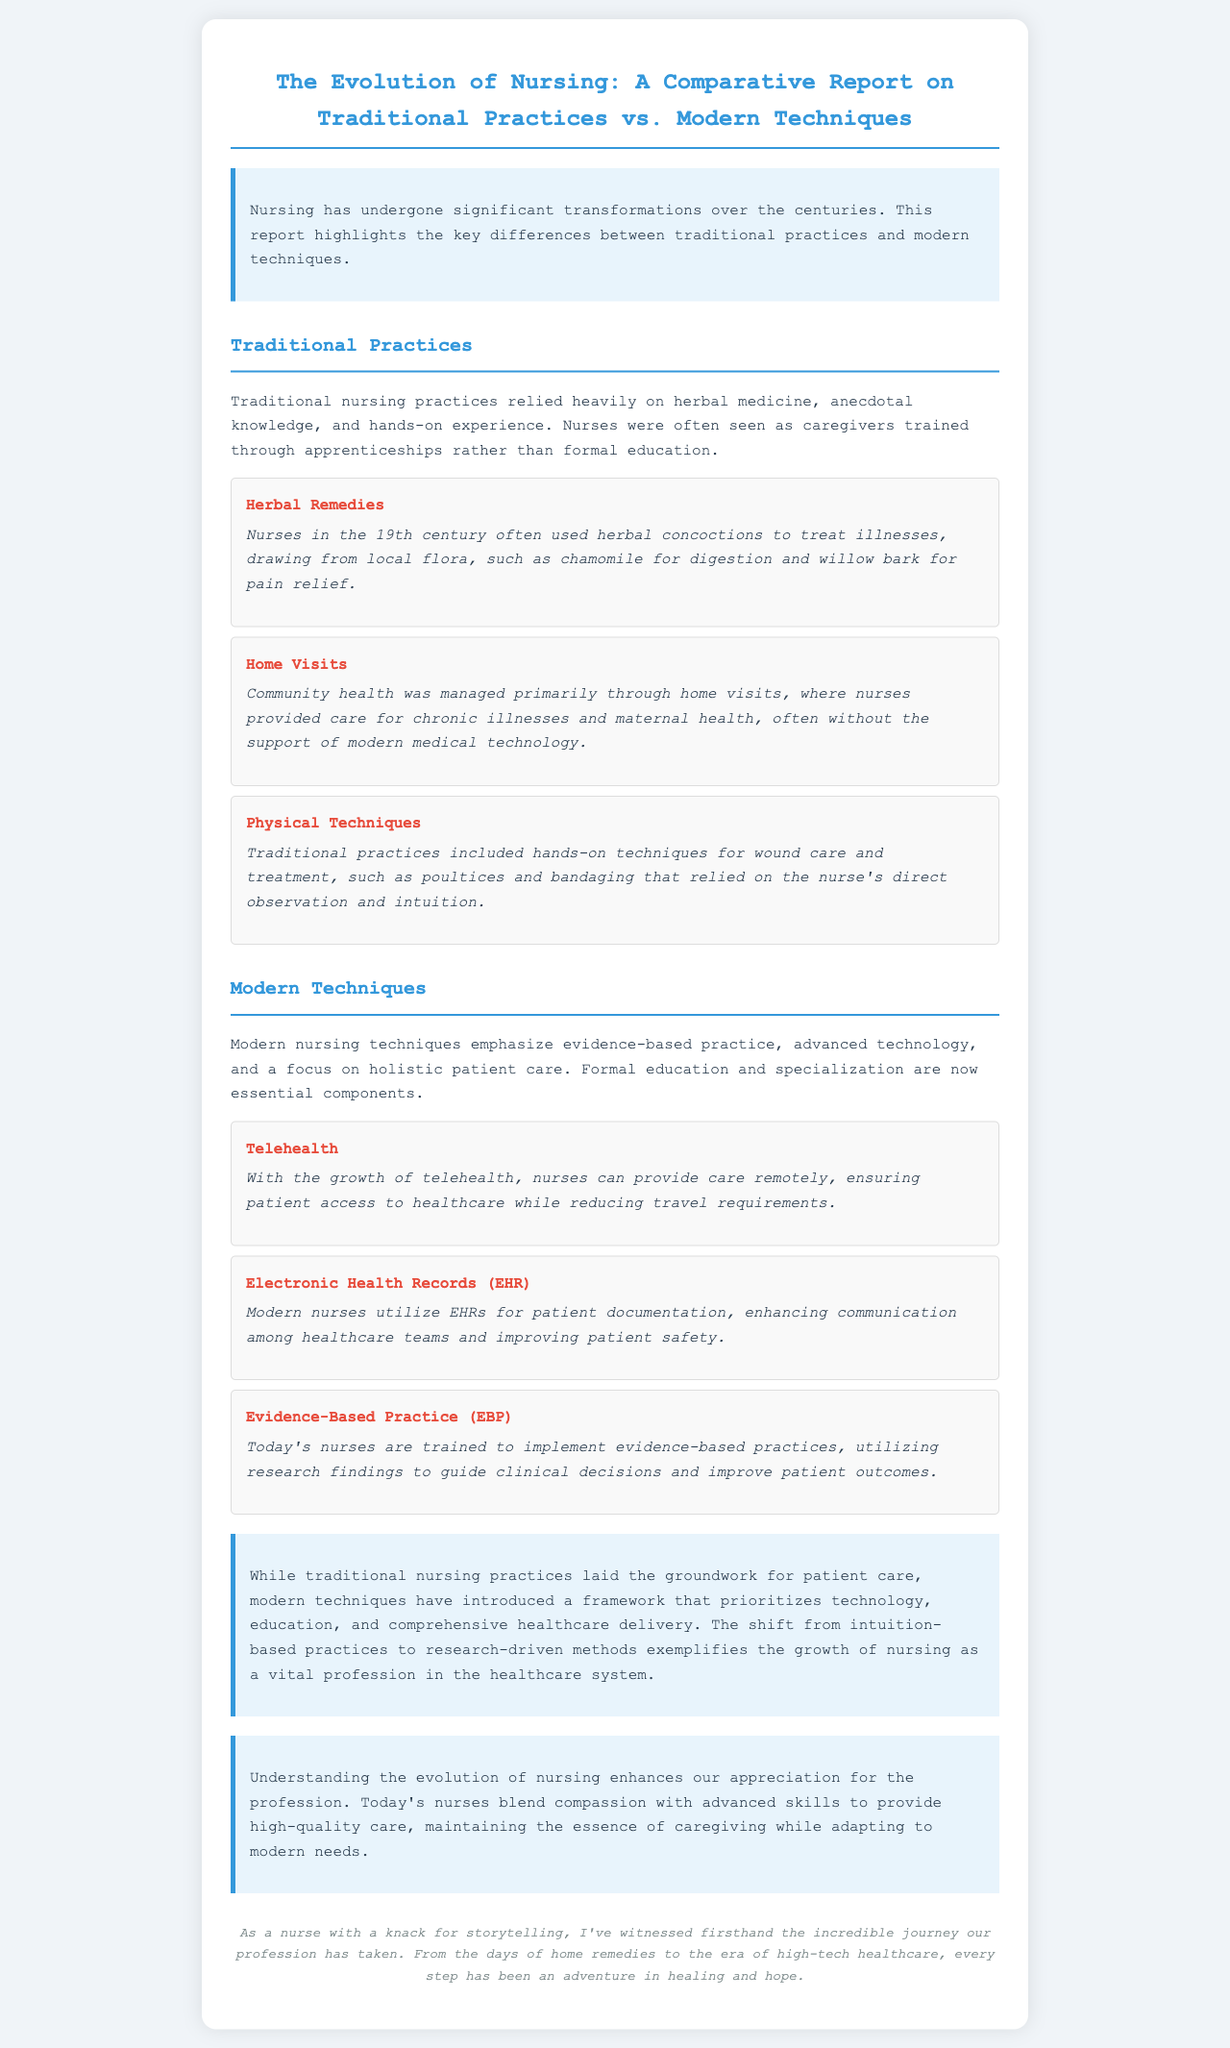what methods did traditional nurses rely on? Traditional nurses relied heavily on herbal medicine, anecdotal knowledge, and hands-on experience.
Answer: herbal medicine, anecdotal knowledge, hands-on experience how were home visits significant in traditional practices? Home visits were crucial for managing community health, allowing nurses to care for chronic illnesses and maternal health.
Answer: community health which technology allows remote patient care today? The document states that telehealth enables nurses to provide care remotely.
Answer: telehealth how do modern nurses enhance communication among healthcare teams? Modern nurses utilize Electronic Health Records (EHR) to enhance communication.
Answer: Electronic Health Records (EHR) what is emphasized in modern nursing techniques? Modern nursing techniques emphasize evidence-based practice, advanced technology, and holistic patient care.
Answer: evidence-based practice, advanced technology, holistic patient care what historical medical practice is mentioned as a technique for pain relief? In the document, the use of willow bark is highlighted as a pain relief technique.
Answer: willow bark what does the shift from traditional practices to modern techniques illustrate about nursing? The shift illustrates growth from intuition-based practices to research-driven methods in nursing.
Answer: growth of nursing as a vital profession how do the modifications in nursing practices improve healthcare delivery? The modifications prioritize technology and education to improve healthcare delivery.
Answer: technology and education 